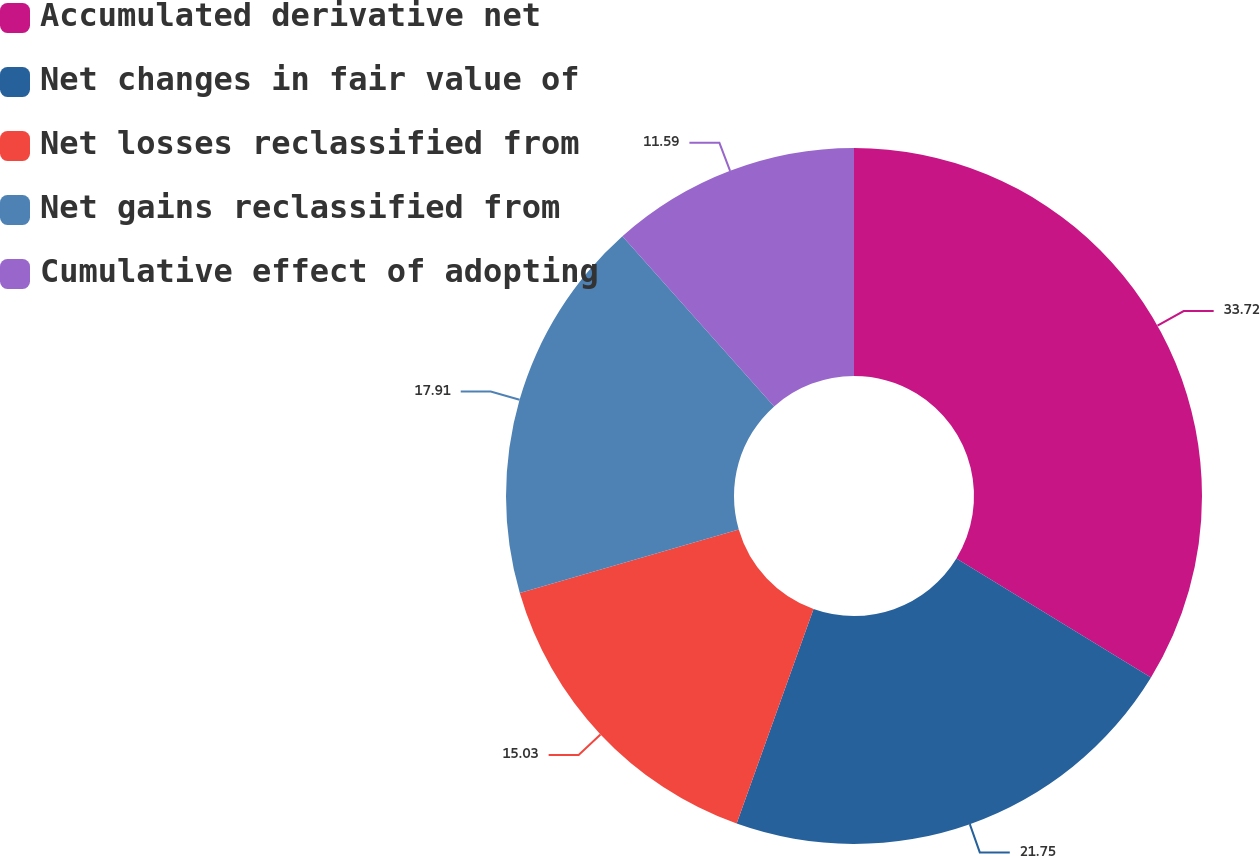Convert chart. <chart><loc_0><loc_0><loc_500><loc_500><pie_chart><fcel>Accumulated derivative net<fcel>Net changes in fair value of<fcel>Net losses reclassified from<fcel>Net gains reclassified from<fcel>Cumulative effect of adopting<nl><fcel>33.73%<fcel>21.75%<fcel>15.03%<fcel>17.91%<fcel>11.59%<nl></chart> 